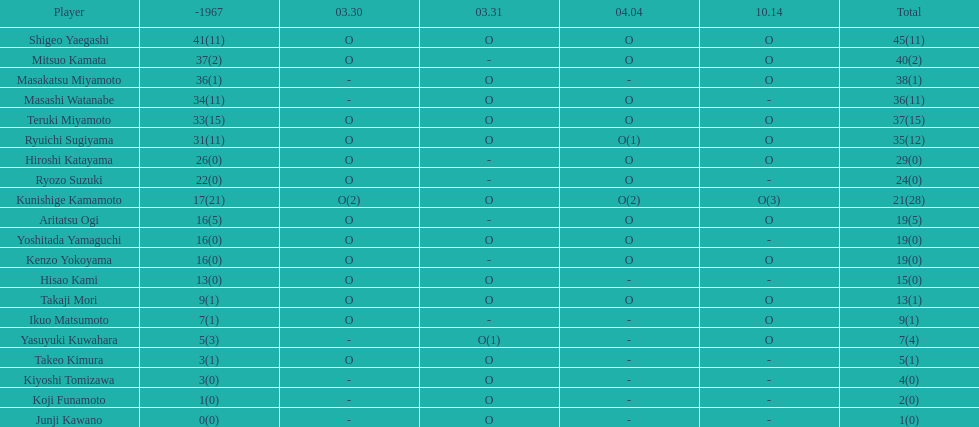How many total did mitsuo kamata have? 40(2). 